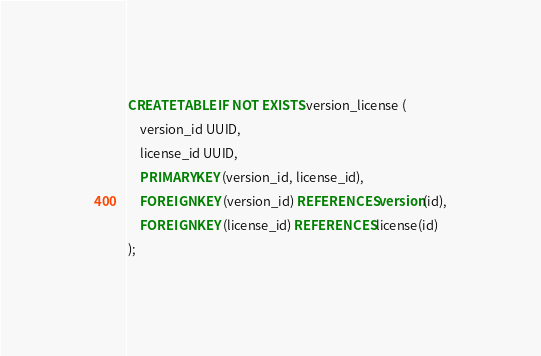<code> <loc_0><loc_0><loc_500><loc_500><_SQL_>CREATE TABLE IF NOT EXISTS version_license (
	version_id UUID,
	license_id UUID,
	PRIMARY KEY (version_id, license_id),
	FOREIGN KEY (version_id) REFERENCES version(id),
	FOREIGN KEY (license_id) REFERENCES license(id)
);</code> 